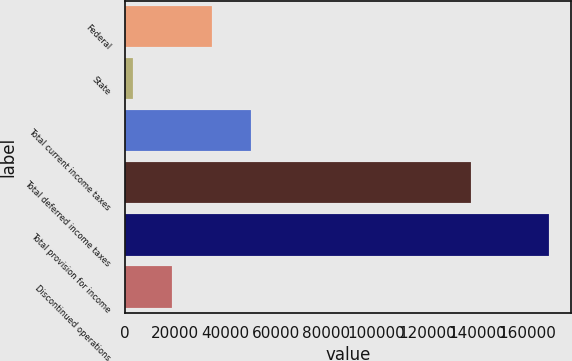<chart> <loc_0><loc_0><loc_500><loc_500><bar_chart><fcel>Federal<fcel>State<fcel>Total current income taxes<fcel>Total deferred income taxes<fcel>Total provision for income<fcel>Discontinued operations<nl><fcel>34393.8<fcel>3311<fcel>49935.2<fcel>137667<fcel>168750<fcel>18852.4<nl></chart> 